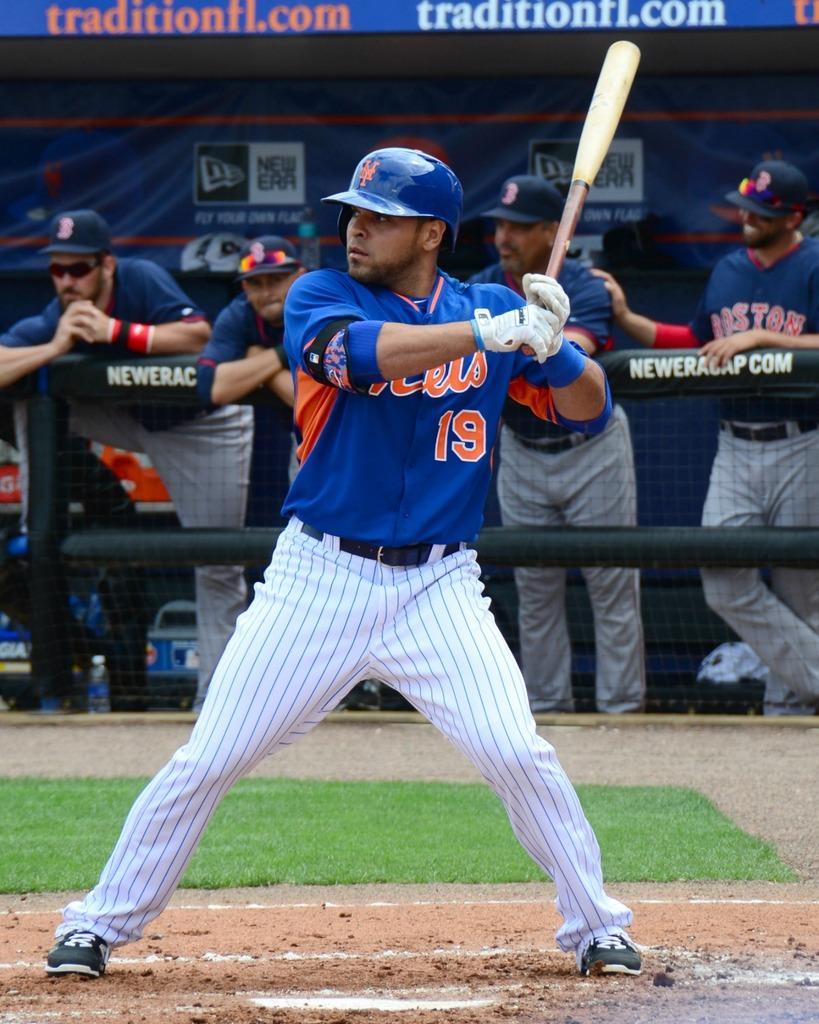<image>
Write a terse but informative summary of the picture. A baseball player gets ready to bat in front of a dugout with players with Boston on their uniforms. 